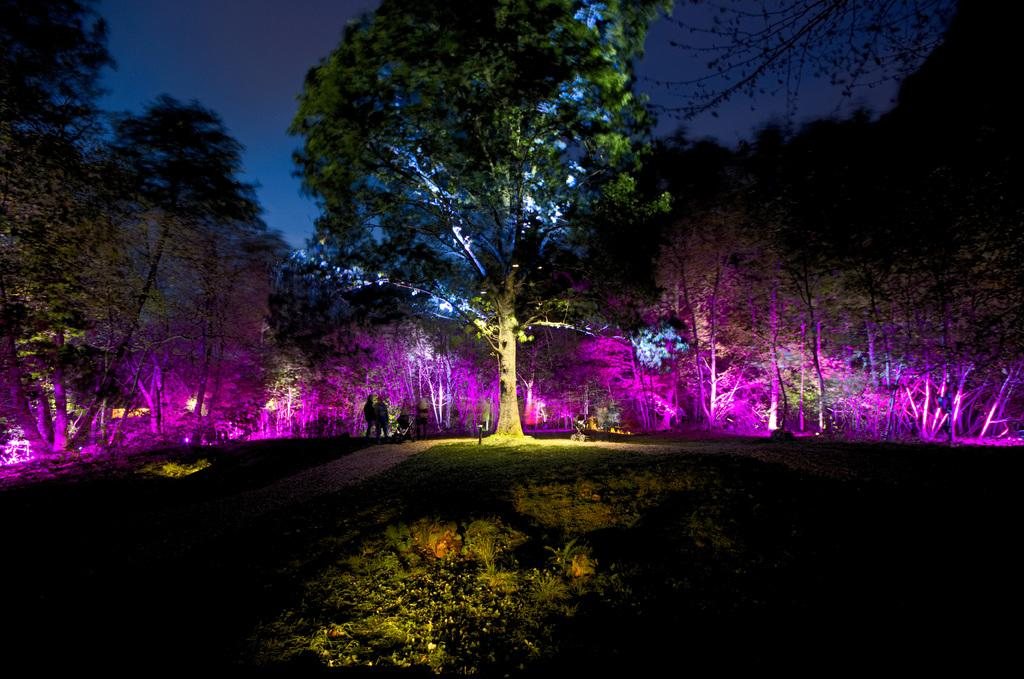What type of vegetation can be seen in the image? There are trees in the image. What are the people in the image doing? The people are standing on the ground in the image. What is visible in the background of the image? The sky is visible in the background of the image. What type of comfort can be seen in the image? There is no specific comfort depicted in the image; it features trees, people standing on the ground, and the sky in the background. Is there a battle taking place in the image? No, there is no battle depicted in the image. 